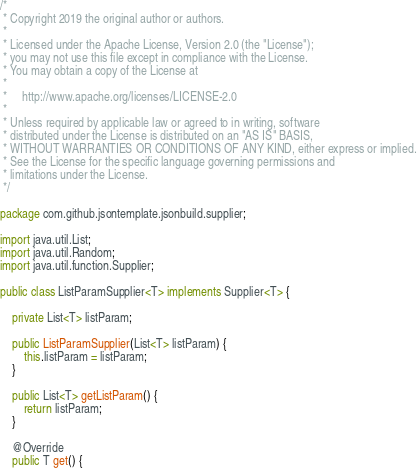<code> <loc_0><loc_0><loc_500><loc_500><_Java_>/*
 * Copyright 2019 the original author or authors.
 *
 * Licensed under the Apache License, Version 2.0 (the "License");
 * you may not use this file except in compliance with the License.
 * You may obtain a copy of the License at
 *
 *     http://www.apache.org/licenses/LICENSE-2.0
 *
 * Unless required by applicable law or agreed to in writing, software
 * distributed under the License is distributed on an "AS IS" BASIS,
 * WITHOUT WARRANTIES OR CONDITIONS OF ANY KIND, either express or implied.
 * See the License for the specific language governing permissions and
 * limitations under the License.
 */

package com.github.jsontemplate.jsonbuild.supplier;

import java.util.List;
import java.util.Random;
import java.util.function.Supplier;

public class ListParamSupplier<T> implements Supplier<T> {

    private List<T> listParam;

    public ListParamSupplier(List<T> listParam) {
        this.listParam = listParam;
    }

    public List<T> getListParam() {
        return listParam;
    }

    @Override
    public T get() {</code> 